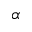Convert formula to latex. <formula><loc_0><loc_0><loc_500><loc_500>\alpha</formula> 